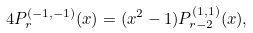<formula> <loc_0><loc_0><loc_500><loc_500>4 P _ { r } ^ { ( - 1 , - 1 ) } ( x ) = ( x ^ { 2 } - 1 ) P _ { r - 2 } ^ { ( 1 , 1 ) } ( x ) ,</formula> 